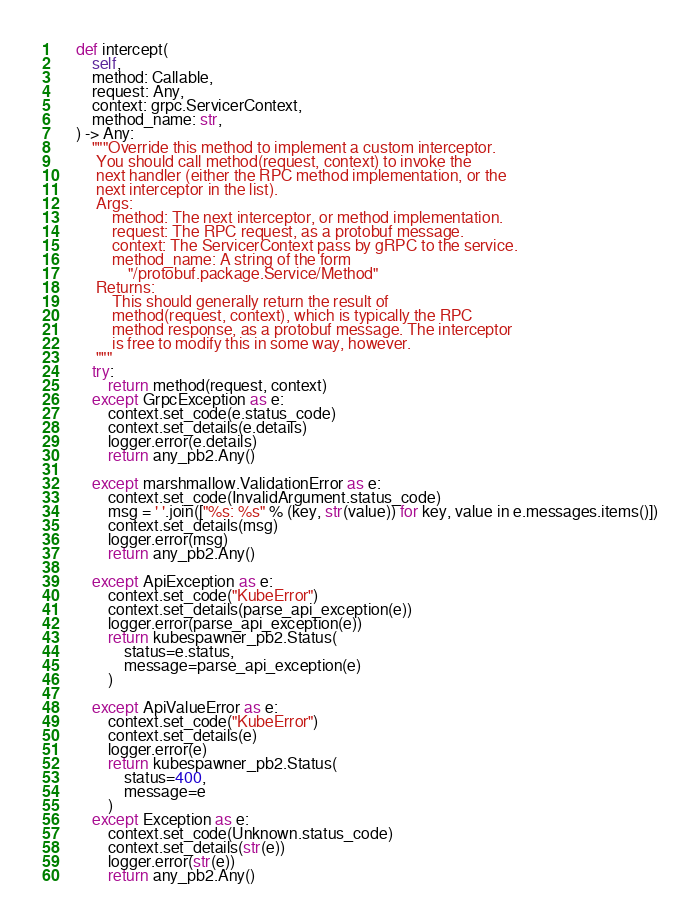Convert code to text. <code><loc_0><loc_0><loc_500><loc_500><_Python_>    def intercept(
        self,
        method: Callable,
        request: Any,
        context: grpc.ServicerContext,
        method_name: str,
    ) -> Any:
        """Override this method to implement a custom interceptor.
         You should call method(request, context) to invoke the
         next handler (either the RPC method implementation, or the
         next interceptor in the list).
         Args:
             method: The next interceptor, or method implementation.
             request: The RPC request, as a protobuf message.
             context: The ServicerContext pass by gRPC to the service.
             method_name: A string of the form
                 "/protobuf.package.Service/Method"
         Returns:
             This should generally return the result of
             method(request, context), which is typically the RPC
             method response, as a protobuf message. The interceptor
             is free to modify this in some way, however.
         """
        try:
            return method(request, context)
        except GrpcException as e:
            context.set_code(e.status_code)
            context.set_details(e.details)
            logger.error(e.details)
            return any_pb2.Any()

        except marshmallow.ValidationError as e:
            context.set_code(InvalidArgument.status_code)
            msg = ' '.join(["%s: %s" % (key, str(value)) for key, value in e.messages.items()])
            context.set_details(msg)
            logger.error(msg)
            return any_pb2.Any()

        except ApiException as e:
            context.set_code("KubeError")
            context.set_details(parse_api_exception(e))
            logger.error(parse_api_exception(e))
            return kubespawner_pb2.Status(
                status=e.status,
                message=parse_api_exception(e)
            )

        except ApiValueError as e:
            context.set_code("KubeError")
            context.set_details(e)
            logger.error(e)
            return kubespawner_pb2.Status(
                status=400,
                message=e
            )
        except Exception as e:
            context.set_code(Unknown.status_code)
            context.set_details(str(e))
            logger.error(str(e))
            return any_pb2.Any()
</code> 